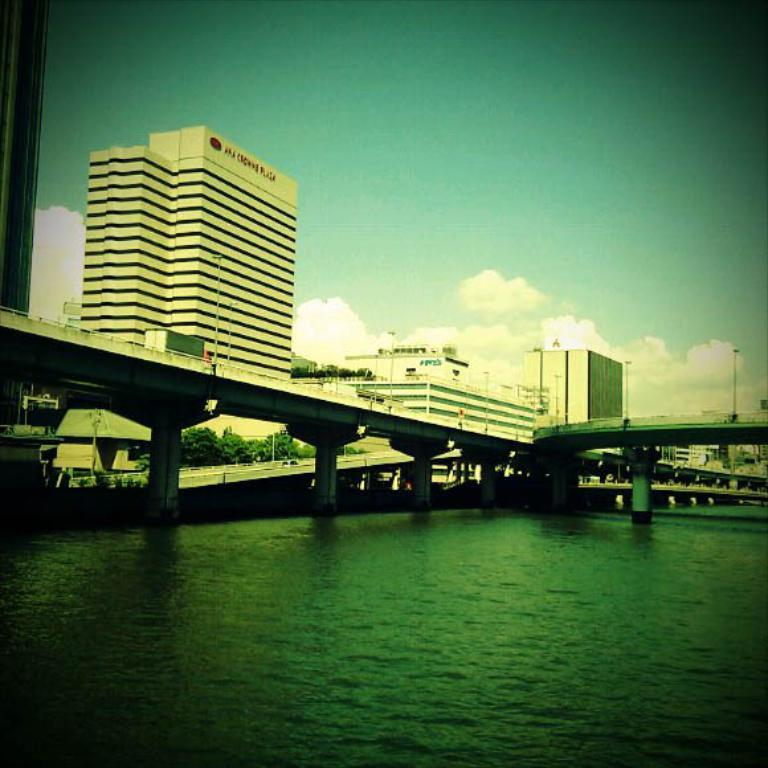What type of structures can be seen in the image? There are buildings in the image. What connects the two sides of the water in the image? There is a bridge in the image. What can be seen flowing beneath the bridge? Water is visible in the image. What is visible above the buildings and bridge in the image? The sky is visible in the image. What can be observed in the sky? Clouds are present in the sky. What type of lighting is present in the image? There is a street light in the image. What type of barrier is present in the image? There is fencing in the image. Can you tell me how many beetles are crawling on the bridge in the image? There are no beetles present on the bridge in the image. What type of adjustment is being made to the street light in the image? There is no adjustment being made to the street light in the image; it is stationary. 